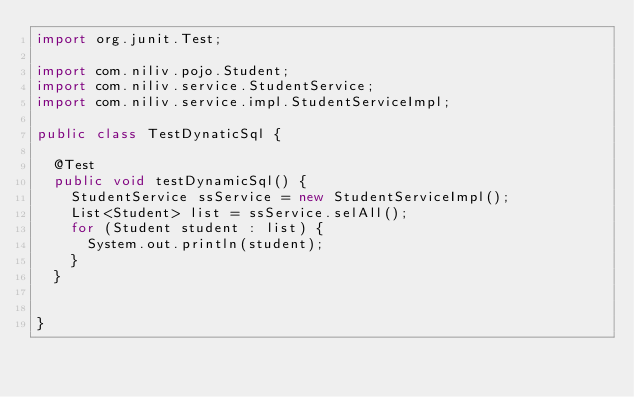<code> <loc_0><loc_0><loc_500><loc_500><_Java_>import org.junit.Test;

import com.niliv.pojo.Student;
import com.niliv.service.StudentService;
import com.niliv.service.impl.StudentServiceImpl;

public class TestDynaticSql {
	
	@Test
	public void testDynamicSql() {
		StudentService ssService = new StudentServiceImpl();
		List<Student> list = ssService.selAll();
		for (Student student : list) {
			System.out.println(student);
		}
	}
	
	
}
</code> 